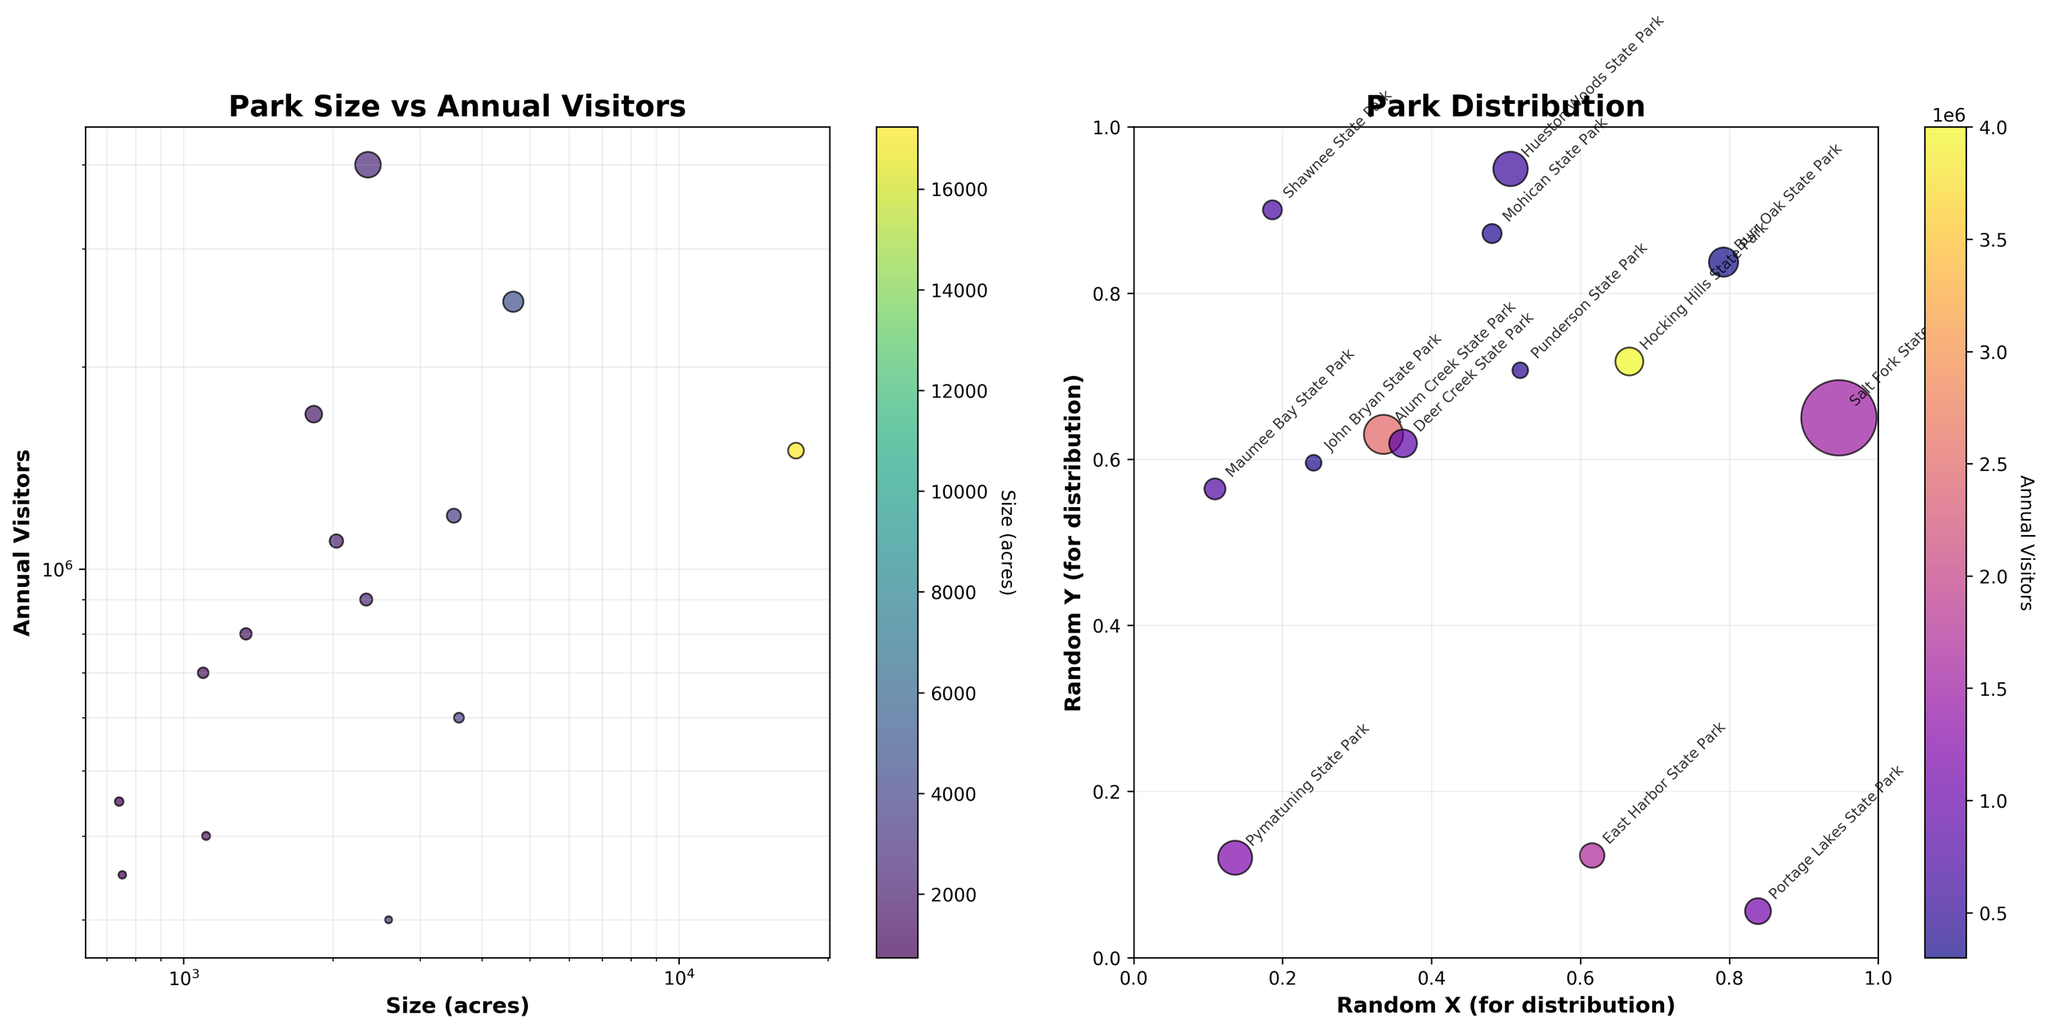What is the title of the first scatter plot on the left? The title of the first scatter plot is written at the top of the left scatter plot.
Answer: Park Size vs Annual Visitors How many data points are there in the figure? The data points correspond to the number of parks listed in the dataset and are shown as dots on the scatter plots.
Answer: 14 Which park has the highest number of annual visitors? By looking at the scatter plot titled "Park Size vs Annual Visitors" and observing the highest y-value, we can identify the corresponding park.
Answer: Hocking Hills State Park Compare the sizes of Maumee Bay State Park and John Bryan State Park. Which one is larger? By referring to the x-axis of the "Park Size vs Annual Visitors" scatter plot, we can compare the sizes of the two mentioned parks.
Answer: Maumee Bay State Park Which park on the left scatter plot is the smallest in size? Look for the data point with the smallest x-value in the "Park Size vs Annual Visitors" scatter plot.
Answer: John Bryan State Park How does the number of visitors to Alum Creek State Park compare to Warren's number of visitors? Find Alum Creek State Park and Warren on the scatter plot, and compare their y-values.
Answer: Alum Creek State Park has more visitors What's the scale used on both the x-axis and y-axis in the left scatter plot? The scale is outlined clearly on the axes labels and their increments in the "Park Size vs Annual Visitors" scatter plot.
Answer: Logarithmic scale In "Park Distribution," are labels attached to each park? We can observe small text strings next to each data point in the right scatter plot, representing the park names.
Answer: Yes How many parks have more than 1 million visitors annually as per the left scatter plot? Identify the data points in the "Park Size vs Annual Visitors" scatter plot with y-values exceeding 1 million. Count these points.
Answer: 6 Which park has a similar size to Burr Oak State Park but more visitors? Look for a data point with an x-value close to that of Burr Oak State Park but a higher y-value in the "Park Size vs Annual Visitors" plot.
Answer: East Harbor State Park 